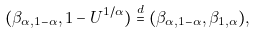Convert formula to latex. <formula><loc_0><loc_0><loc_500><loc_500>( \beta _ { \alpha , 1 - \alpha } , 1 - U ^ { 1 / \alpha } ) \stackrel { d } { = } ( \beta _ { \alpha , 1 - \alpha } , \beta _ { 1 , \alpha } ) ,</formula> 